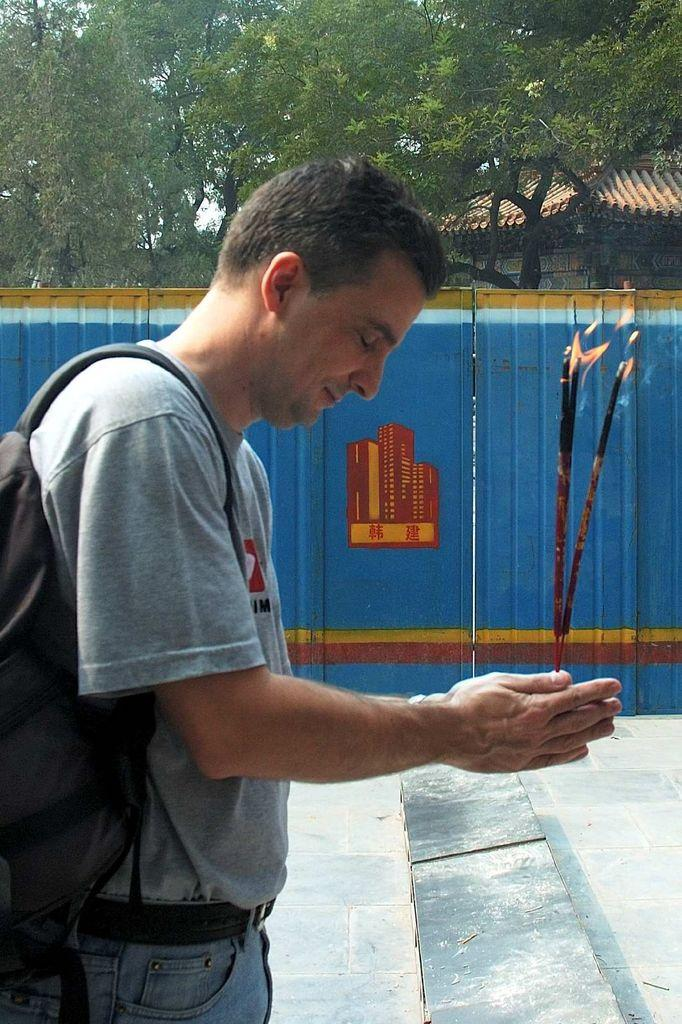What is the man in the image doing? The man is standing in the image and holding incense sticks. What is the man wearing in the image? The man is wearing a bag. What can be seen in the background of the image? There is a building in the background of the image. What type of vegetation is visible in the image? There are trees in the image. What is the color of the fence in the image? The fence in the image is blue. What type of news can be seen on the paper in the image? There is no paper or news present in the image; it features a man holding incense sticks and standing near a blue fence. 